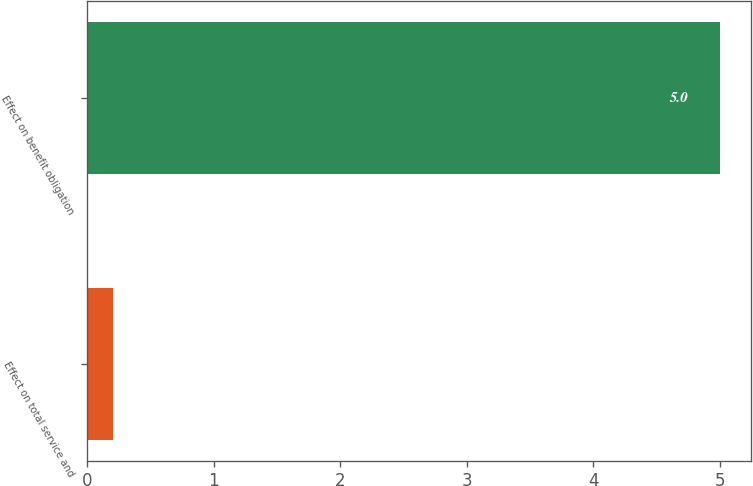<chart> <loc_0><loc_0><loc_500><loc_500><bar_chart><fcel>Effect on total service and<fcel>Effect on benefit obligation<nl><fcel>0.2<fcel>5<nl></chart> 